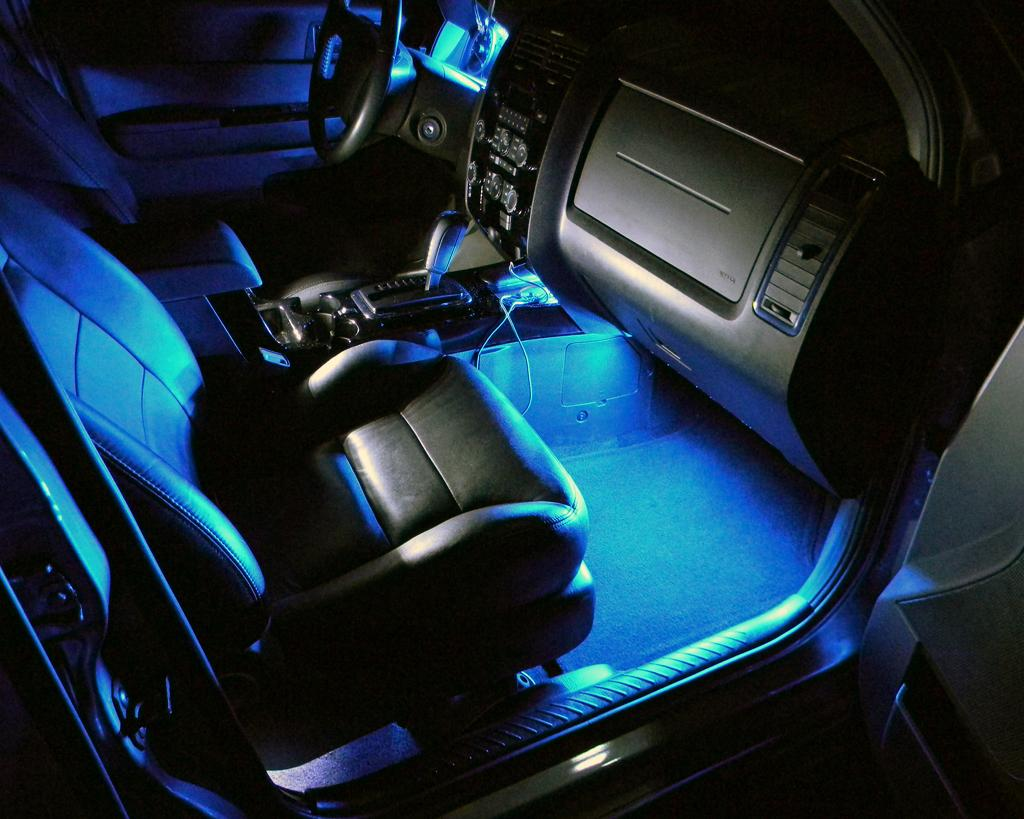What type of space is depicted in the image? The image shows an inside view of a vehicle. What is the primary control mechanism for the vehicle? There is a steering wheel in the image. How can the driver change the vehicle's speed and direction? There is a gear rod in the image. What is provided for passengers to sit in the vehicle? There are seats in the image. Can you describe any additional objects visible in the image? There are some objects visible in the image. What type of mountain range can be seen through the window in the image? There is no window or mountain range visible in the image; it shows an inside view of a vehicle. What kind of flowers are growing on the dashboard in the image? There are no flowers present in the image; it only shows the interior of a vehicle with a steering wheel, gear rod, seats, and some objects. 